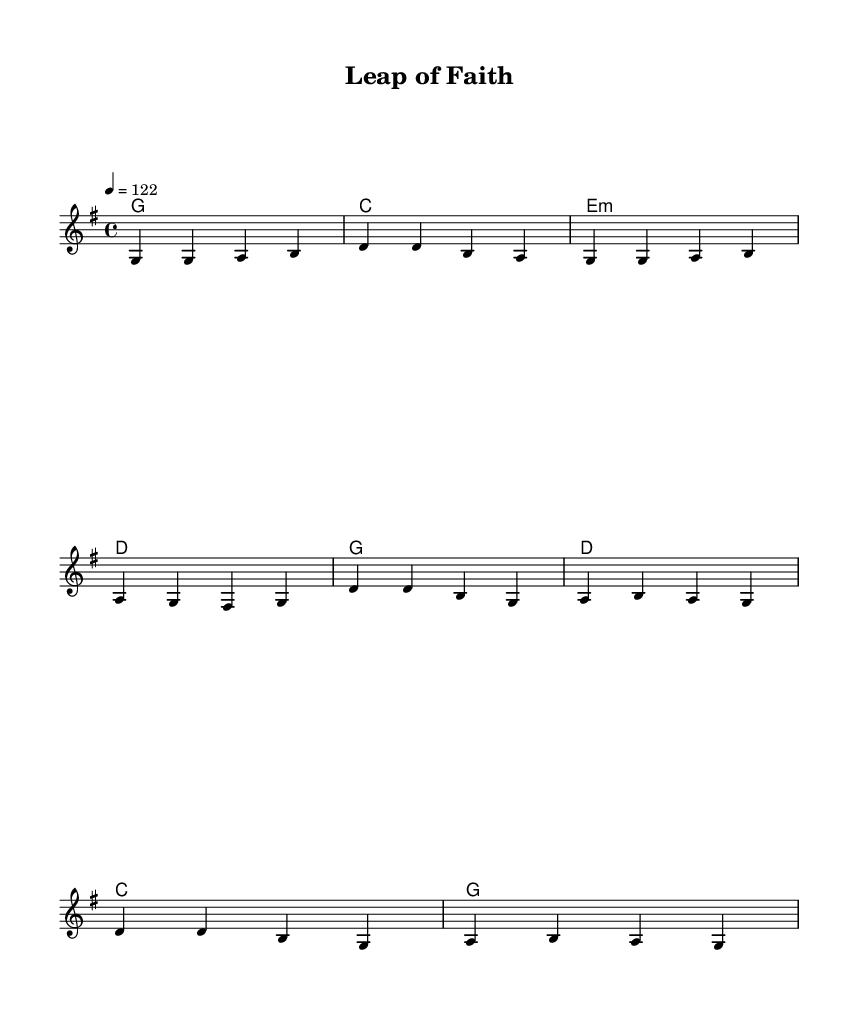What is the key signature of this music? The key signature is G major, which has one sharp (F#).
Answer: G major What is the time signature of this music? The time signature is 4/4, indicating four beats per measure.
Answer: 4/4 What is the tempo marking for this score? The tempo is marked as quarter note = 122 beats per minute.
Answer: 122 How many measures are in the verse section? The verse section consists of four measures, as indicated by the grouping of the notes.
Answer: Four measures What type of song structure is used in this piece? The song uses a verse-chorus structure, comprising both a verse and a chorus.
Answer: Verse-chorus What is the main theme of the lyrics in the chorus? The theme of the chorus is about taking risks and embracing opportunities, expressed through the phrase "leap of faith."
Answer: Taking risks What is the harmonic progression for the chorus? The harmonic progression for the chorus follows the chords G, D, C, and G, creating a familiar country sound.
Answer: G, D, C, G 